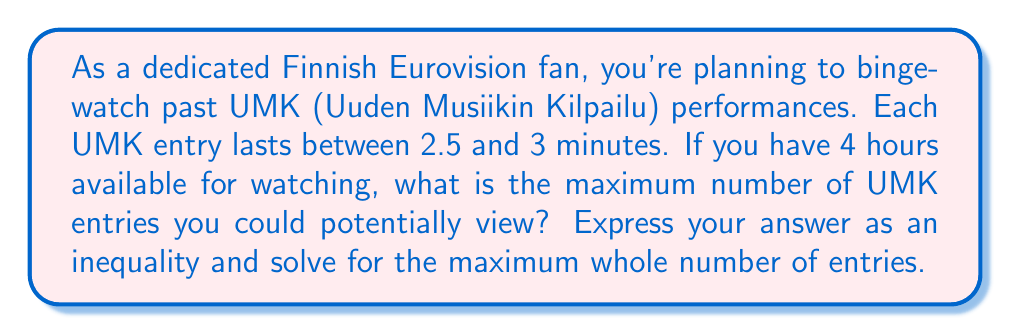Can you solve this math problem? Let's approach this step-by-step:

1) Let $x$ be the number of UMK entries.

2) Each entry lasts at least 2.5 minutes and at most 3 minutes.

3) The total time available is 4 hours = 240 minutes.

4) To find the maximum number of entries, we use the minimum duration per entry (2.5 minutes).

5) We can express this as an inequality:

   $2.5x \leq 240$

6) Solving for $x$:

   $$\begin{align}
   2.5x &\leq 240 \\
   x &\leq 240 / 2.5 \\
   x &\leq 96
   \end{align}$$

7) Since we're looking for the maximum whole number of entries, we need to round down to the nearest integer.

8) Therefore, the maximum number of entries is 96.

9) We can verify: $96 * 2.5 = 240$ minutes, which exactly fits our time constraint.

10) Note that if any song were longer than 2.5 minutes, we couldn't fit all 96 entries.
Answer: $x \leq 96$, where $x$ is the maximum number of UMK entries that can be watched in 4 hours. 